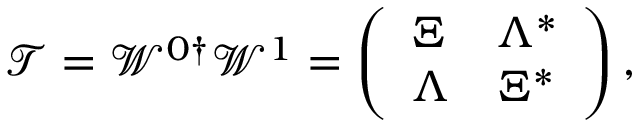<formula> <loc_0><loc_0><loc_500><loc_500>\mathcal { T } = \mathcal { W } ^ { 0 \dag } \mathcal { W } ^ { 1 } = \left ( \begin{array} { l l } { \Xi } & { \Lambda ^ { * } } \\ { \Lambda } & { \Xi ^ { * } } \end{array} \right ) ,</formula> 